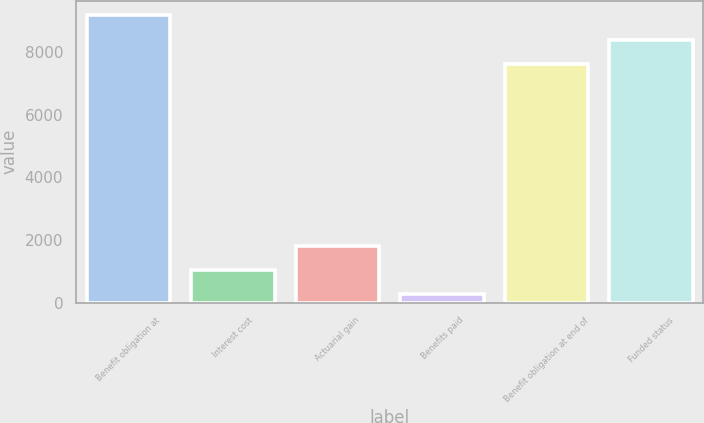<chart> <loc_0><loc_0><loc_500><loc_500><bar_chart><fcel>Benefit obligation at<fcel>Interest cost<fcel>Actuarial gain<fcel>Benefits paid<fcel>Benefit obligation at end of<fcel>Funded status<nl><fcel>9174.6<fcel>1040.8<fcel>1814.6<fcel>267<fcel>7627<fcel>8400.8<nl></chart> 